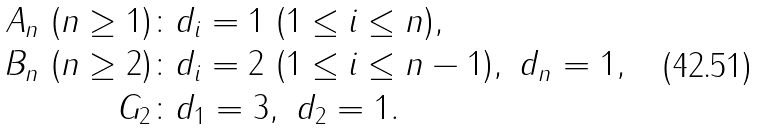Convert formula to latex. <formula><loc_0><loc_0><loc_500><loc_500>A _ { n } \ ( n \geq 1 ) \colon & d _ { i } = 1 \ ( 1 \leq i \leq n ) , \\ B _ { n } \ ( n \geq 2 ) \colon & d _ { i } = 2 \ ( 1 \leq i \leq n - 1 ) , \ d _ { n } = 1 , \\ G _ { 2 } \colon & d _ { 1 } = 3 , \ d _ { 2 } = 1 .</formula> 